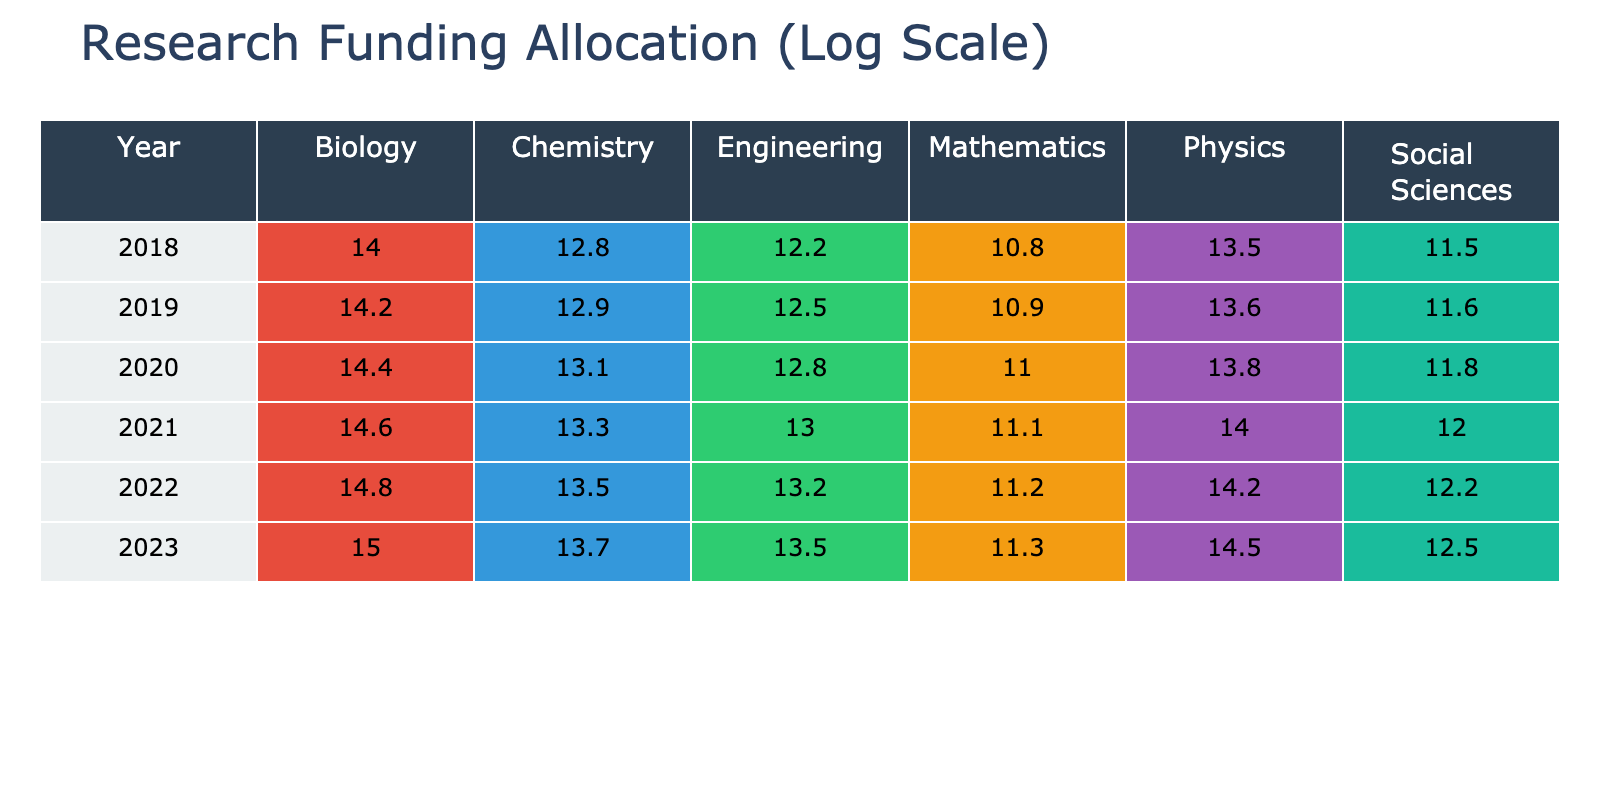What was the funding amount for Biology in 2020? In the table, we look for the row corresponding to the year 2020 and find the value in the Biology column. The funding amount for Biology in 2020 is 14.4 (log scale).
Answer: 14.4 Which discipline received the highest funding in 2021? By examining the 2021 row across all disciplines, we see that the Biology discipline has the highest logarithmic funding amount of 14.6.
Answer: Biology What is the sum of funding amounts for Engineering from 2018 to 2023? We need to find the Engineering funding amounts for each year: 12.2 (2018), 12.5 (2019), 12.8 (2020), 13.0 (2021), 13.2 (2022), and 13.5 (2023). Adding these values gives us 12.2 + 12.5 + 12.8 + 13.0 + 13.2 + 13.5 = 73.2.
Answer: 73.2 Is the statement "Chemistry funding in 2022 is greater than Physics funding in 2021" true? To evaluate this, we check the Chemistry funding amount for 2022 which is 13.5 and the Physics funding amount for 2021 which is 14.0. Since 13.5 is not greater than 14.0, the statement is false.
Answer: No What is the average funding amount for Social Sciences from 2019 to 2023? First, we find the Social Sciences funding amounts: 11.6 (2019), 11.8 (2020), 12.0 (2021), 12.2 (2022), and 12.5 (2023). The sum of these values is 11.6 + 11.8 + 12.0 + 12.2 + 12.5 = 60.1. There are 5 years, so the average is 60.1 / 5 = 12.02.
Answer: 12.02 Which discipline saw the most significant increase in funding from 2018 to 2023? We will compare the change in funding for each discipline from 2018 to 2023 by calculating the difference. For Physics: 14.5 - 13.5 = 1.0; Chemistry: 13.7 - 12.8 = 0.9; Biology: 15.0 - 14.0 = 1.0; Engineering: 13.5 - 12.2 = 1.3; Social Sciences: 12.5 - 11.5 = 1.0; Mathematics: 11.3 - 10.8 = 0.5. Engineering had the largest increase of 1.3 log units.
Answer: Engineering 